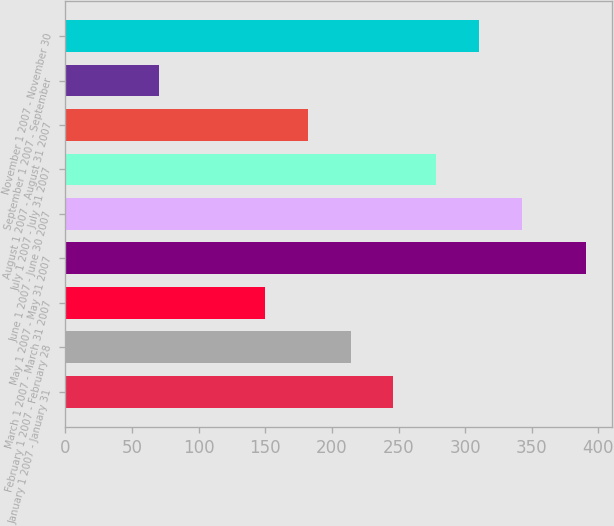Convert chart to OTSL. <chart><loc_0><loc_0><loc_500><loc_500><bar_chart><fcel>January 1 2007 - January 31<fcel>February 1 2007 - February 28<fcel>March 1 2007 - March 31 2007<fcel>May 1 2007 - May 31 2007<fcel>June 1 2007 - June 30 2007<fcel>July 1 2007 - July 31 2007<fcel>August 1 2007 - August 31 2007<fcel>September 1 2007 - September<fcel>November 1 2007 - November 30<nl><fcel>246.21<fcel>214.14<fcel>150<fcel>390.7<fcel>342.42<fcel>278.28<fcel>182.07<fcel>70<fcel>310.35<nl></chart> 